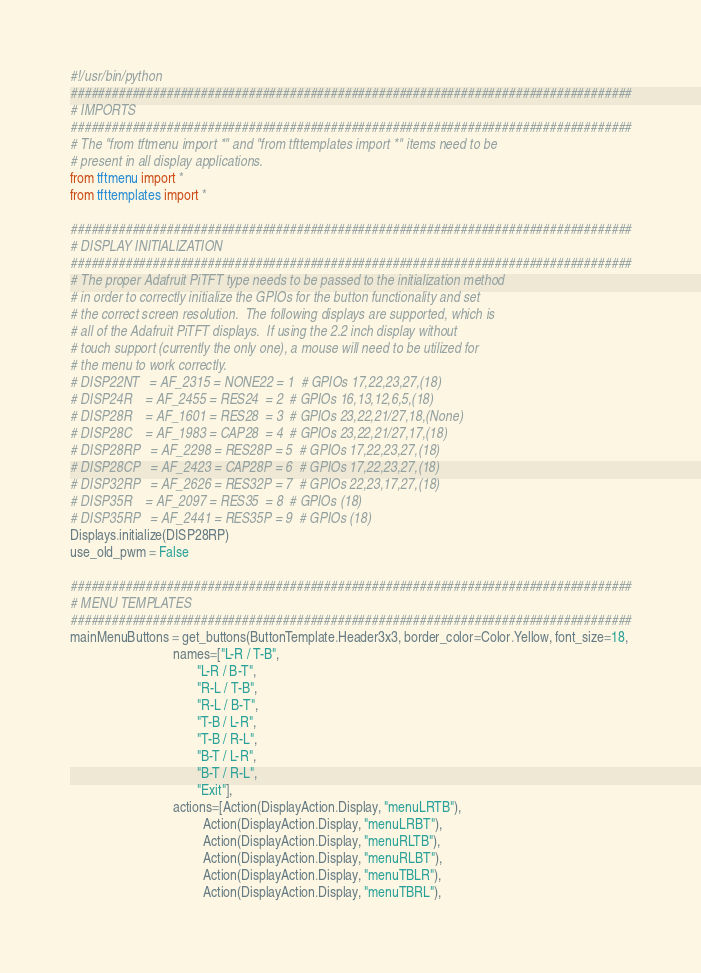<code> <loc_0><loc_0><loc_500><loc_500><_Python_>#!/usr/bin/python
##################################################################################
# IMPORTS
##################################################################################
# The "from tftmenu import *" and "from tfttemplates import *" items need to be
# present in all display applications.
from tftmenu import *
from tfttemplates import *

##################################################################################
# DISPLAY INITIALIZATION
##################################################################################
# The proper Adafruit PiTFT type needs to be passed to the initialization method
# in order to correctly initialize the GPIOs for the button functionality and set
# the correct screen resolution.  The following displays are supported, which is
# all of the Adafruit PiTFT displays.  If using the 2.2 inch display without
# touch support (currently the only one), a mouse will need to be utilized for
# the menu to work correctly.
# DISP22NT   = AF_2315 = NONE22 = 1  # GPIOs 17,22,23,27,(18)
# DISP24R    = AF_2455 = RES24  = 2  # GPIOs 16,13,12,6,5,(18)
# DISP28R    = AF_1601 = RES28  = 3  # GPIOs 23,22,21/27,18,(None)
# DISP28C    = AF_1983 = CAP28  = 4  # GPIOs 23,22,21/27,17,(18)
# DISP28RP   = AF_2298 = RES28P = 5  # GPIOs 17,22,23,27,(18)
# DISP28CP   = AF_2423 = CAP28P = 6  # GPIOs 17,22,23,27,(18)
# DISP32RP   = AF_2626 = RES32P = 7  # GPIOs 22,23,17,27,(18)
# DISP35R    = AF_2097 = RES35  = 8  # GPIOs (18)
# DISP35RP   = AF_2441 = RES35P = 9  # GPIOs (18)
Displays.initialize(DISP28RP)
use_old_pwm = False

##################################################################################
# MENU TEMPLATES
##################################################################################
mainMenuButtons = get_buttons(ButtonTemplate.Header3x3, border_color=Color.Yellow, font_size=18,
                              names=["L-R / T-B",
                                     "L-R / B-T",
                                     "R-L / T-B",
                                     "R-L / B-T",
                                     "T-B / L-R",
                                     "T-B / R-L",
                                     "B-T / L-R",
                                     "B-T / R-L",
                                     "Exit"],
                              actions=[Action(DisplayAction.Display, "menuLRTB"),
                                       Action(DisplayAction.Display, "menuLRBT"),
                                       Action(DisplayAction.Display, "menuRLTB"),
                                       Action(DisplayAction.Display, "menuRLBT"),
                                       Action(DisplayAction.Display, "menuTBLR"),
                                       Action(DisplayAction.Display, "menuTBRL"),</code> 